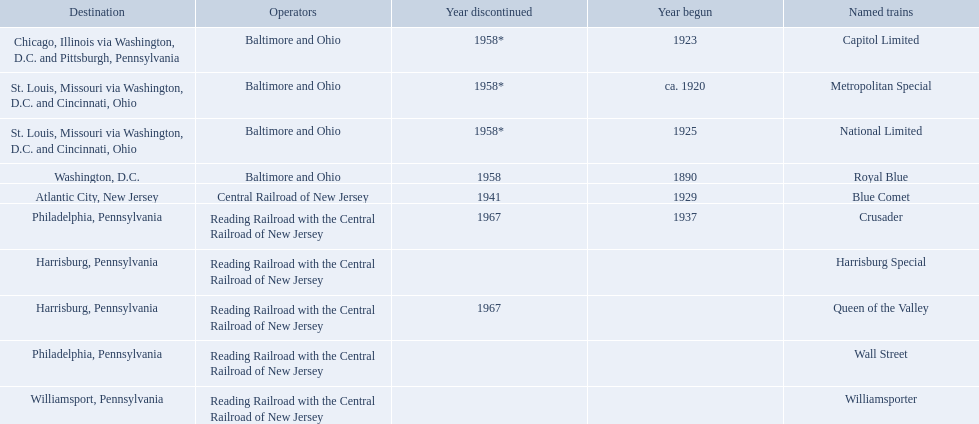What were all of the destinations? Chicago, Illinois via Washington, D.C. and Pittsburgh, Pennsylvania, St. Louis, Missouri via Washington, D.C. and Cincinnati, Ohio, St. Louis, Missouri via Washington, D.C. and Cincinnati, Ohio, Washington, D.C., Atlantic City, New Jersey, Philadelphia, Pennsylvania, Harrisburg, Pennsylvania, Harrisburg, Pennsylvania, Philadelphia, Pennsylvania, Williamsport, Pennsylvania. And what were the names of the trains? Capitol Limited, Metropolitan Special, National Limited, Royal Blue, Blue Comet, Crusader, Harrisburg Special, Queen of the Valley, Wall Street, Williamsporter. Of those, and along with wall street, which train ran to philadelphia, pennsylvania? Crusader. 